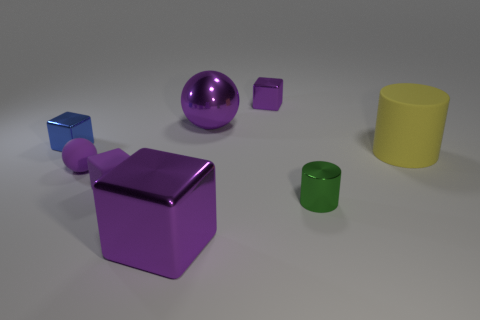Subtract all gray cylinders. How many purple blocks are left? 3 Subtract 1 blocks. How many blocks are left? 3 Add 1 tiny cylinders. How many objects exist? 9 Subtract all balls. How many objects are left? 6 Add 5 small rubber spheres. How many small rubber spheres exist? 6 Subtract 0 purple cylinders. How many objects are left? 8 Subtract all purple blocks. Subtract all big balls. How many objects are left? 4 Add 4 small purple matte spheres. How many small purple matte spheres are left? 5 